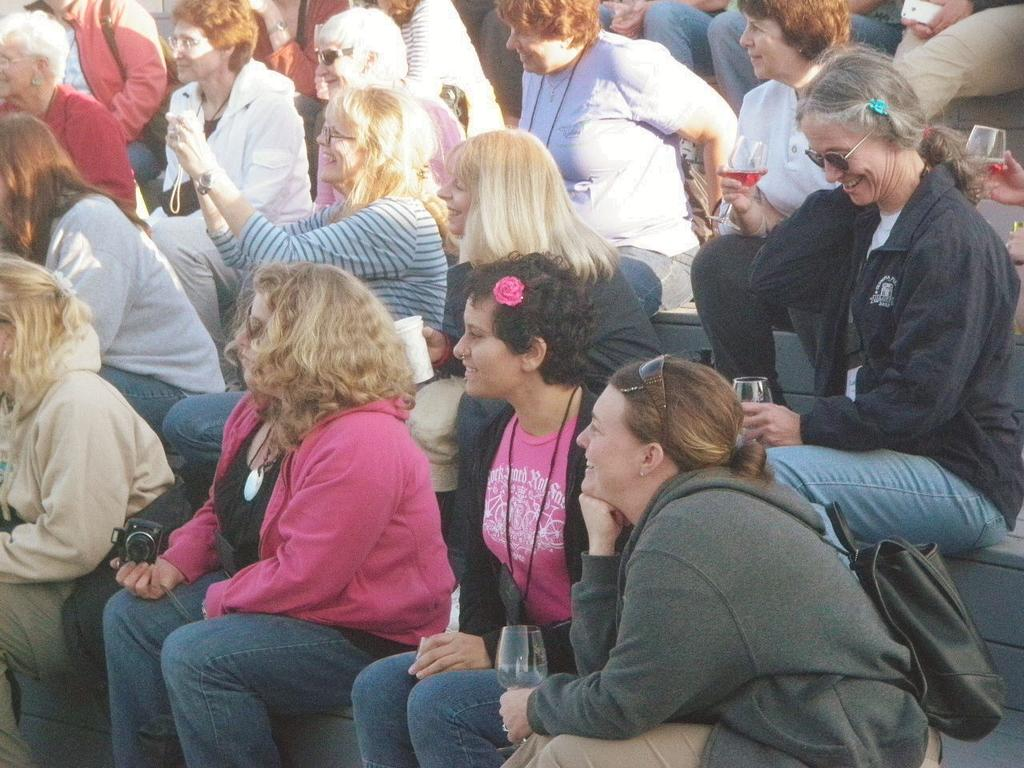What is the main focus of the image? The main focus of the image is the people in the center. What are some people doing in the image? Some people are holding glasses, and some are taking photos. Is the minister in the image having trouble with the map? There is no minister or map present in the image. 